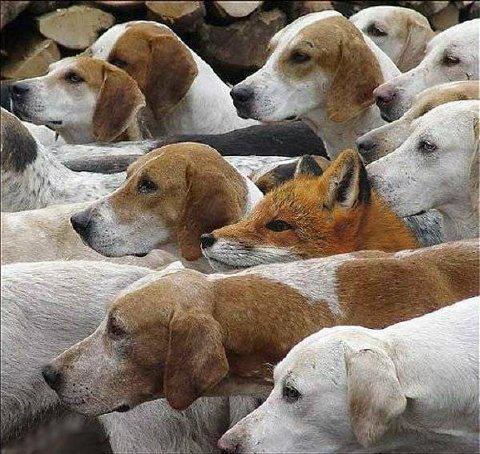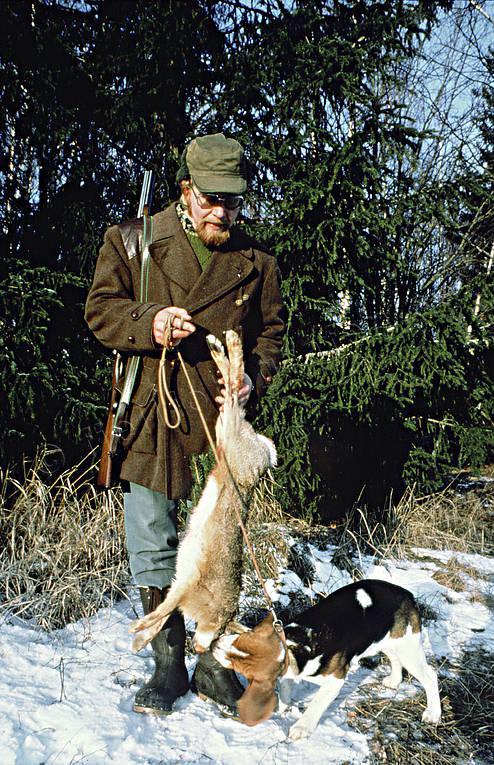The first image is the image on the left, the second image is the image on the right. Considering the images on both sides, is "A single dog is standing on the ground in the image on the right." valid? Answer yes or no. Yes. The first image is the image on the left, the second image is the image on the right. Considering the images on both sides, is "One image shows a beagle standing on all fours with no other being present, and the other image shows at least 8 beagles, which are not in a single row." valid? Answer yes or no. No. 